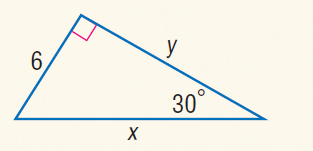Answer the mathemtical geometry problem and directly provide the correct option letter.
Question: Find x.
Choices: A: \sqrt { 6 } B: 6 C: 6 \sqrt { 3 } D: 12 D 